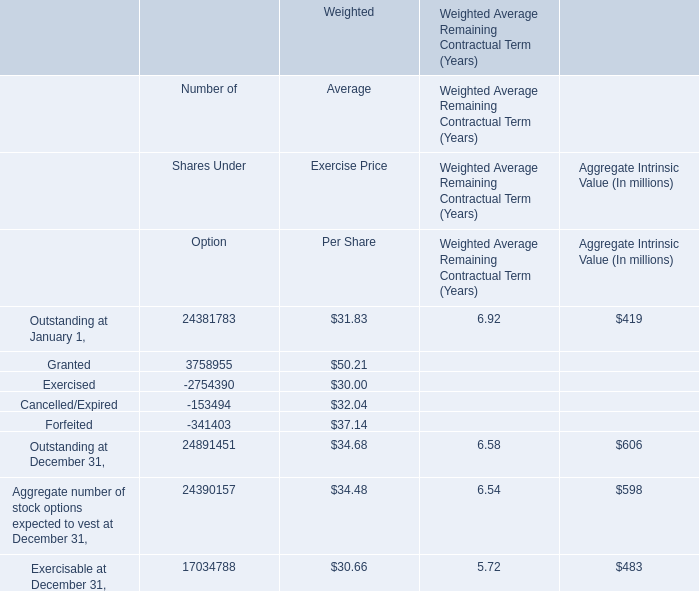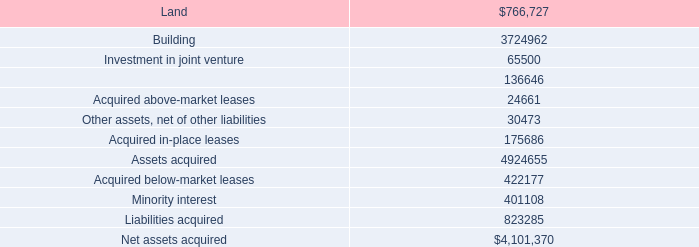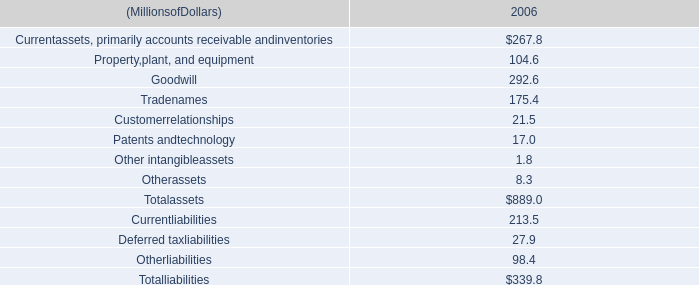Which element exceeds 20% of total elements for Aggregate Intrinsic Value? 
Answer: Outstanding at December 31, Aggregate number of stock options expected to vest at December 31, Exercisable at December 31. 